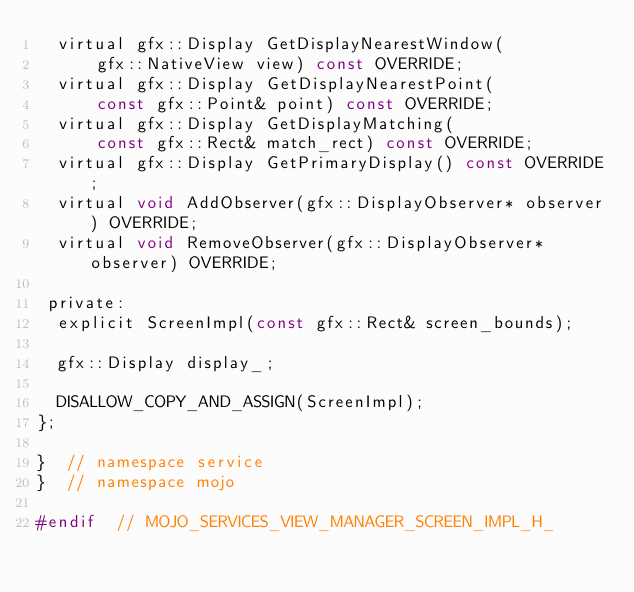Convert code to text. <code><loc_0><loc_0><loc_500><loc_500><_C_>  virtual gfx::Display GetDisplayNearestWindow(
      gfx::NativeView view) const OVERRIDE;
  virtual gfx::Display GetDisplayNearestPoint(
      const gfx::Point& point) const OVERRIDE;
  virtual gfx::Display GetDisplayMatching(
      const gfx::Rect& match_rect) const OVERRIDE;
  virtual gfx::Display GetPrimaryDisplay() const OVERRIDE;
  virtual void AddObserver(gfx::DisplayObserver* observer) OVERRIDE;
  virtual void RemoveObserver(gfx::DisplayObserver* observer) OVERRIDE;

 private:
  explicit ScreenImpl(const gfx::Rect& screen_bounds);

  gfx::Display display_;

  DISALLOW_COPY_AND_ASSIGN(ScreenImpl);
};

}  // namespace service
}  // namespace mojo

#endif  // MOJO_SERVICES_VIEW_MANAGER_SCREEN_IMPL_H_
</code> 